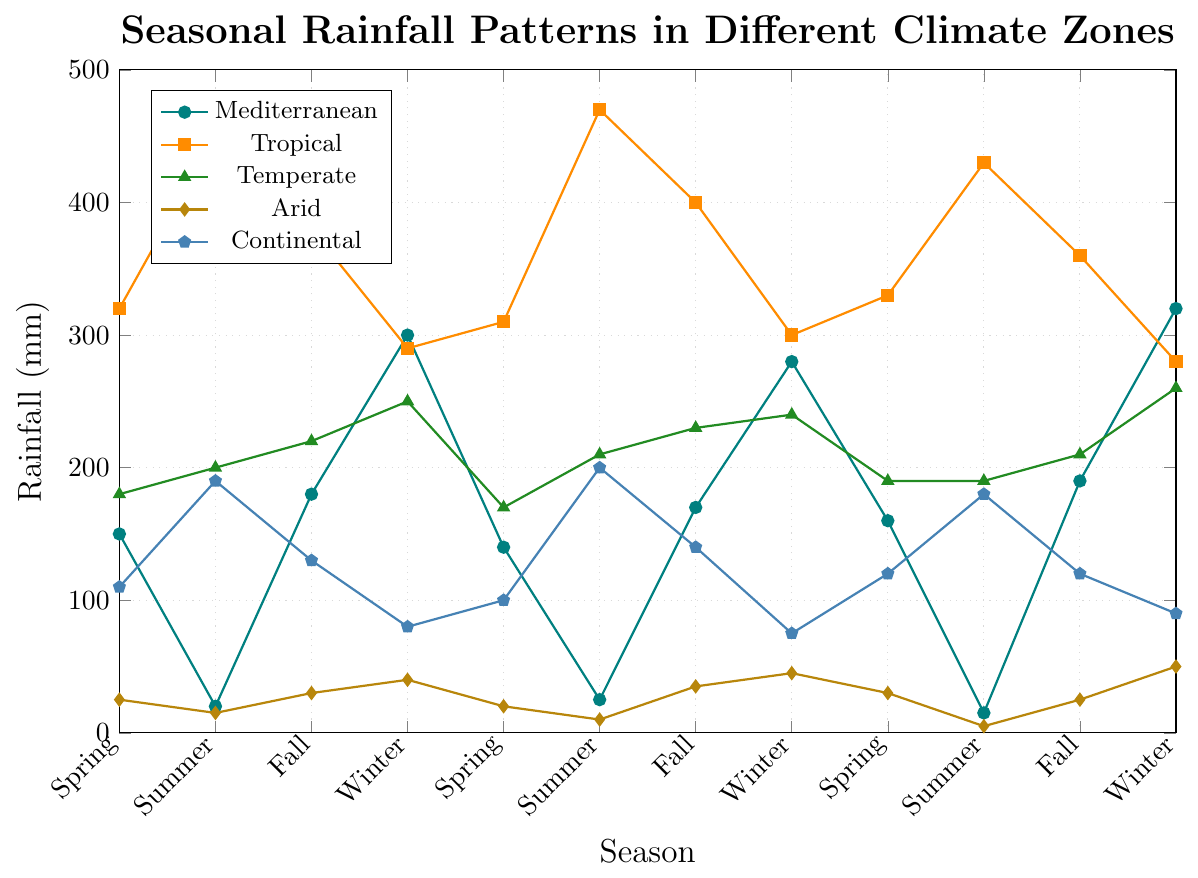What season shows the highest rainfall for the Mediterranean climate? Look at the data points for the Mediterranean climate across all seasons. The highest value is visible in Winter at 320 mm.
Answer: Winter Which climate zone has the least fluctuation in rainfall across all seasons? Measure the range of rainfall (difference between highest and lowest values) across seasons for each climate zone. Arid has the smallest range, varying only from 5 mm in Summer to 50 mm in Winter.
Answer: Arid During Fall, which climate zone receives the most rainfall? Check the Fall data points for all climate zones: Mediterranean (180 mm, 170 mm, 190 mm), Tropical (380 mm, 400 mm, 360 mm), Temperate (220 mm, 230 mm, 210 mm), Arid (30 mm, 35 mm, 25 mm), and Continental (130 mm, 140 mm, 120 mm). Tropical has the maximum in Fall.
Answer: Tropical What is the average rainfall for the Temperate climate in Winter over the years provided? The Temperate rainfall in Winter across three years is: 250 mm, 240 mm, and 260 mm. The average is (250 + 240 + 260) / 3 = 750 / 3 = 250 mm.
Answer: 250 mm By how much does the rainfall in Summer for Tropical climate exceed that of the Mediterranean climate? Compare the Summer data points for Tropical (450 mm, 470 mm, 430 mm) and Mediterranean (20 mm, 25 mm, 15 mm) climates. The average excess is (450+470+430)/3 - (20+25+15)/3 = 450 mm.
Answer: 450 mm Which season shows the least rainfall for the Arid climate? From the Arid climate data, locate the lowest value across all seasons. It is 5 mm in Summer.
Answer: Summer 